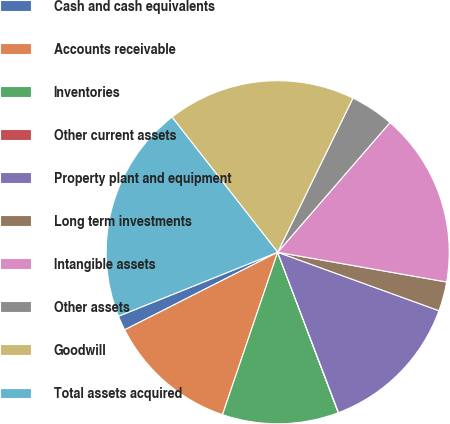Convert chart to OTSL. <chart><loc_0><loc_0><loc_500><loc_500><pie_chart><fcel>Cash and cash equivalents<fcel>Accounts receivable<fcel>Inventories<fcel>Other current assets<fcel>Property plant and equipment<fcel>Long term investments<fcel>Intangible assets<fcel>Other assets<fcel>Goodwill<fcel>Total assets acquired<nl><fcel>1.39%<fcel>12.32%<fcel>10.96%<fcel>0.03%<fcel>13.69%<fcel>2.76%<fcel>16.42%<fcel>4.13%<fcel>17.79%<fcel>20.52%<nl></chart> 